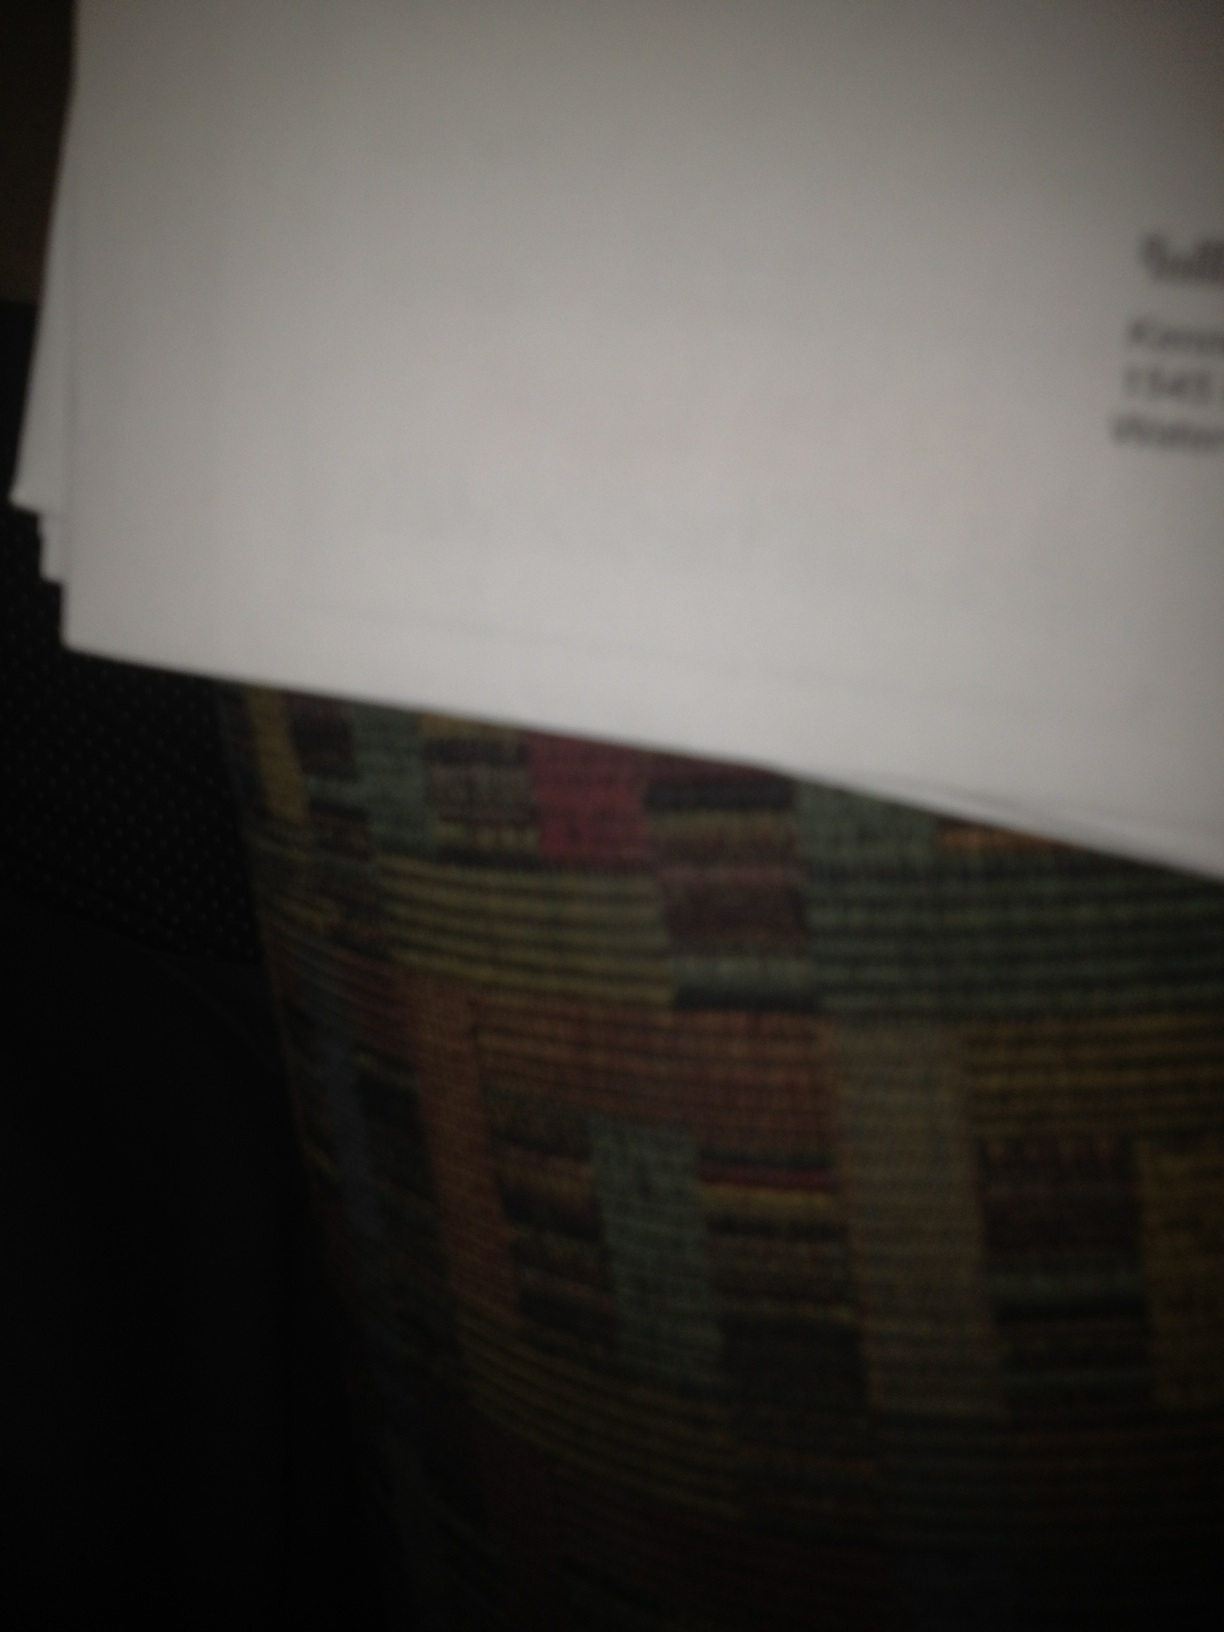Who's letter is this from? It's difficult to determine who the letter is from just by looking at the blurred image. To find out, you might consider checking any clearer parts of the letter or any visible logos or signatures that could hint at the sender. 